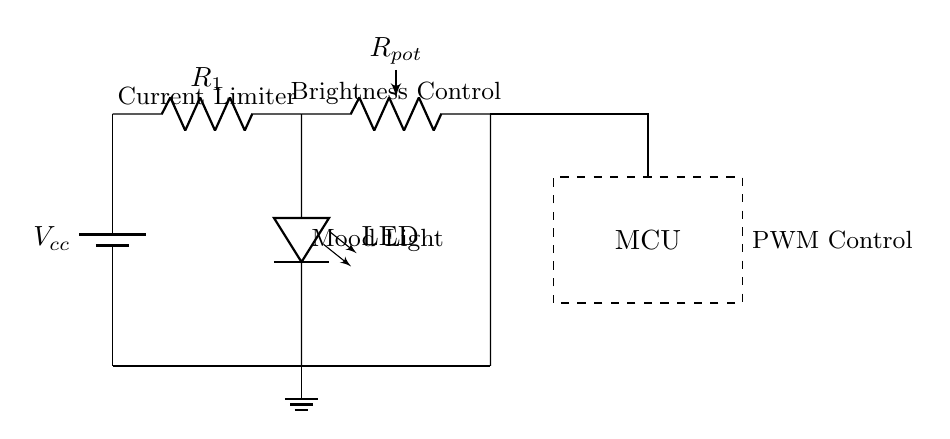What type of power source is used in this circuit? The circuit utilizes a battery as the power source, which is indicated by the symbol for a battery labeled with Vcc.
Answer: Battery What is the function of R1 in this circuit? R1 is a current limiting resistor. It is placed in series with the LED to prevent excessive current from flowing through the LED, which could damage it.
Answer: Current limiting What component is used for brightness control? The component used for brightness control is a potentiometer, labeled as Rpot, which allows the user to adjust the resistance and therefore the brightness of the LED.
Answer: Potentiometer How many main components can you identify in the circuit? The circuit contains three main components: the battery, LED, and the current limiting resistor. Each plays a crucial role in the functionality of the lighting circuit.
Answer: Three What does the dashed rectangle in the circuit represent? The dashed rectangle represents a microcontroller unit (MCU), indicating that it is included for controlling the LED's brightness through PWM (Pulse Width Modulation).
Answer: Microcontroller How is the LED connected in relation to the other components? The LED is connected in series with the current limiting resistor R1 and in parallel with the potentiometer, forming part of the potential circuit loop.
Answer: In series with R1 What function does PWM serve in this circuit? PWM stands for Pulse Width Modulation and it is used for controlling the brightness of the LED by varying the width of the voltage pulses sent to the LED, allowing for dimming effects.
Answer: Brightness control 